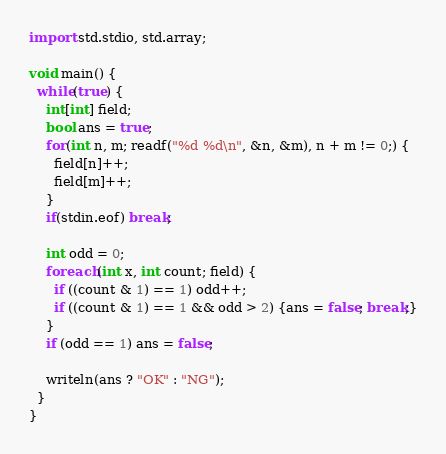Convert code to text. <code><loc_0><loc_0><loc_500><loc_500><_D_>
import std.stdio, std.array;

void main() {
  while(true) {
    int[int] field;
    bool ans = true;
    for(int n, m; readf("%d %d\n", &n, &m), n + m != 0;) {
      field[n]++;
      field[m]++;
    }
    if(stdin.eof) break;

    int odd = 0;
    foreach(int x, int count; field) {
      if ((count & 1) == 1) odd++;
      if ((count & 1) == 1 && odd > 2) {ans = false; break;}
    }
    if (odd == 1) ans = false;

    writeln(ans ? "OK" : "NG");
  }
}</code> 